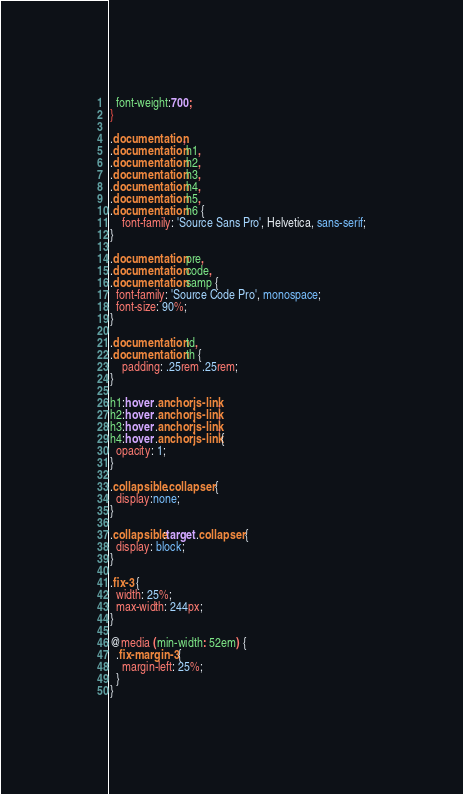Convert code to text. <code><loc_0><loc_0><loc_500><loc_500><_CSS_>  font-weight:700;
}

.documentation,
.documentation h1,
.documentation h2,
.documentation h3,
.documentation h4,
.documentation h5,
.documentation h6 {
    font-family: 'Source Sans Pro', Helvetica, sans-serif;
}

.documentation pre,
.documentation code,
.documentation samp {
  font-family: 'Source Code Pro', monospace;
  font-size: 90%;
}

.documentation td,
.documentation th {
    padding: .25rem .25rem;
}

h1:hover .anchorjs-link,
h2:hover .anchorjs-link,
h3:hover .anchorjs-link,
h4:hover .anchorjs-link {
  opacity: 1;
}

.collapsible .collapser {
  display:none;
}

.collapsible:target .collapser {
  display: block;
}

.fix-3 {
  width: 25%;
  max-width: 244px;
}

@media (min-width: 52em) {
  .fix-margin-3 {
    margin-left: 25%;
  }
}
</code> 